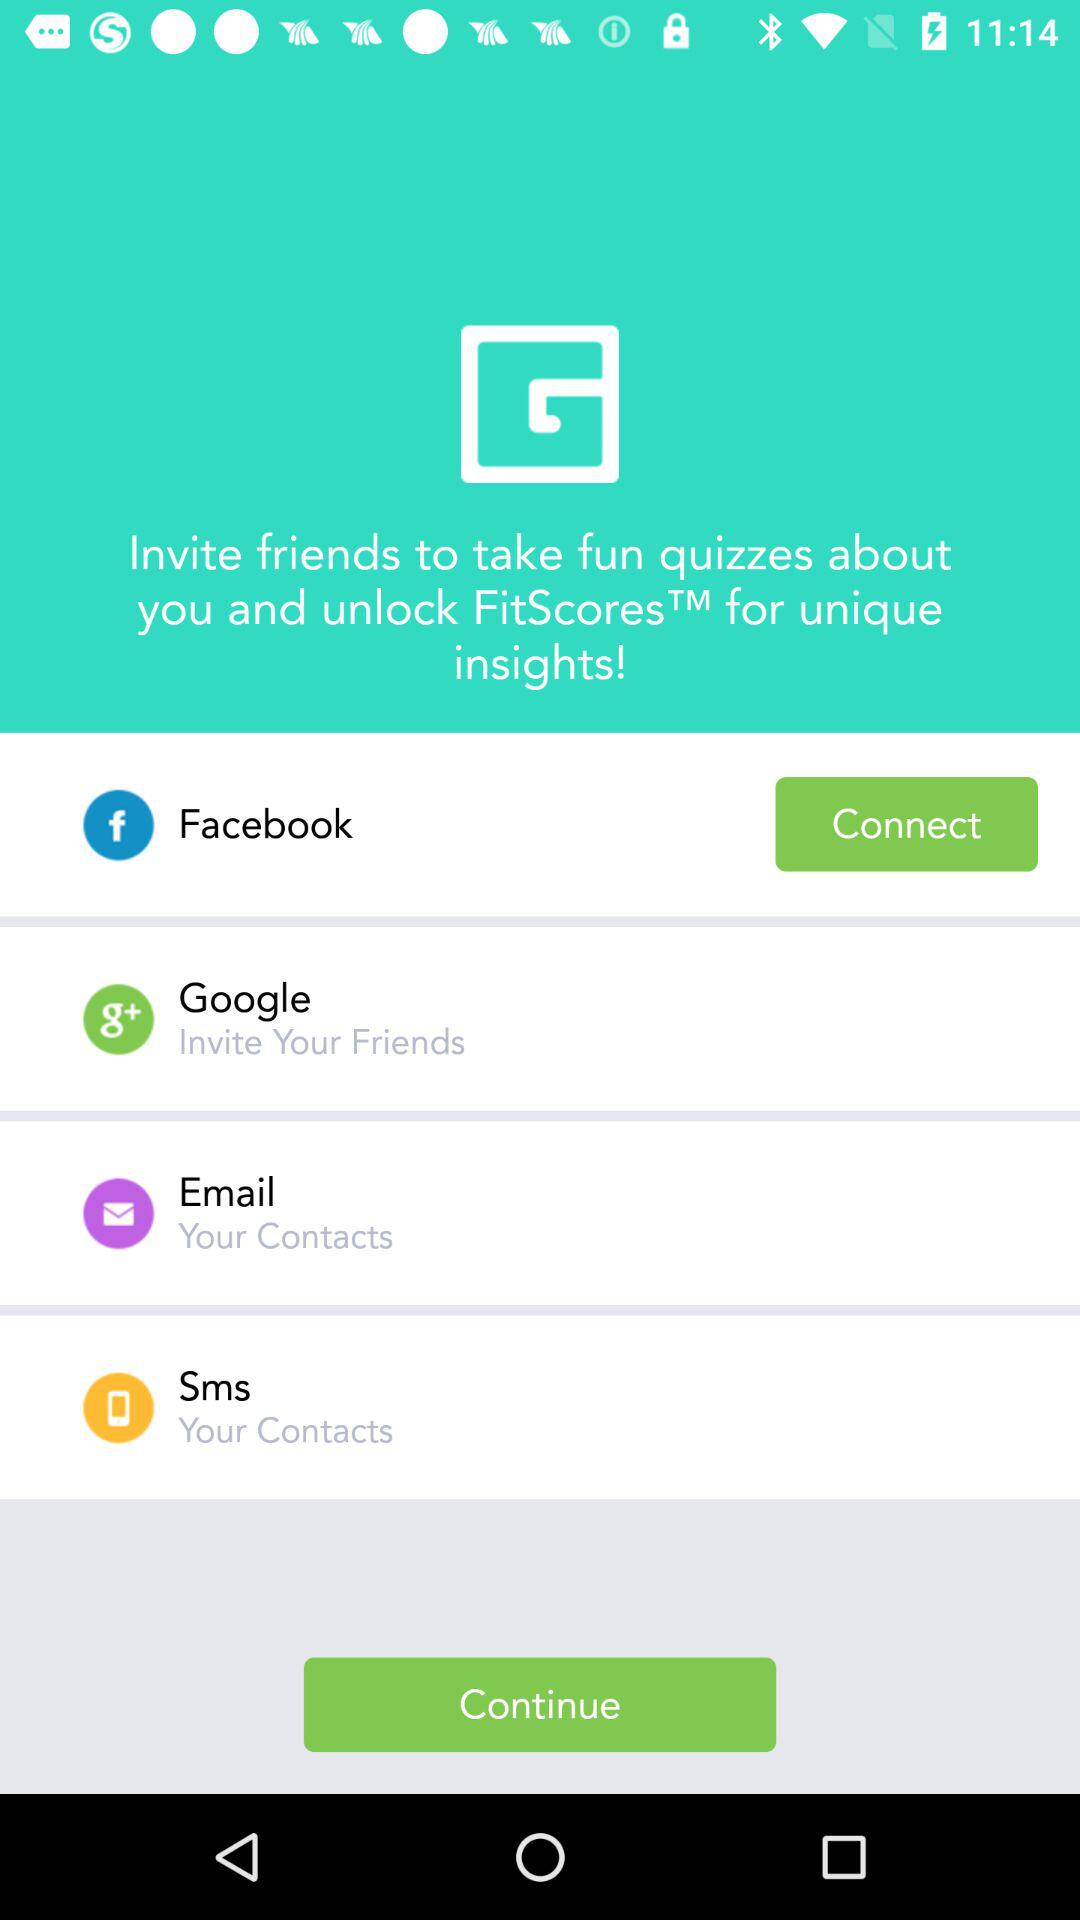What is the name of the application through which the user can connect? The name of the application through which the user can connect is "Facebook". 